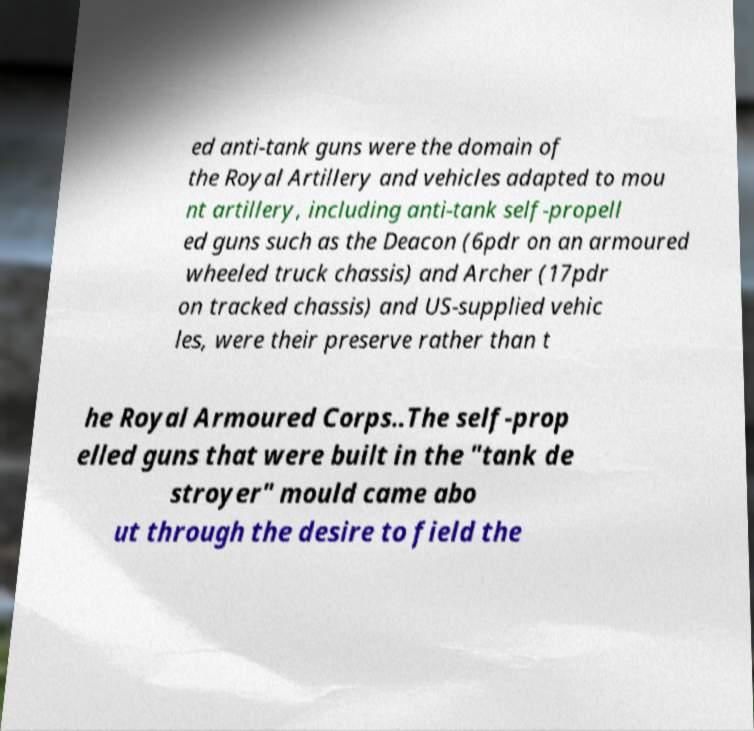Can you read and provide the text displayed in the image?This photo seems to have some interesting text. Can you extract and type it out for me? ed anti-tank guns were the domain of the Royal Artillery and vehicles adapted to mou nt artillery, including anti-tank self-propell ed guns such as the Deacon (6pdr on an armoured wheeled truck chassis) and Archer (17pdr on tracked chassis) and US-supplied vehic les, were their preserve rather than t he Royal Armoured Corps..The self-prop elled guns that were built in the "tank de stroyer" mould came abo ut through the desire to field the 